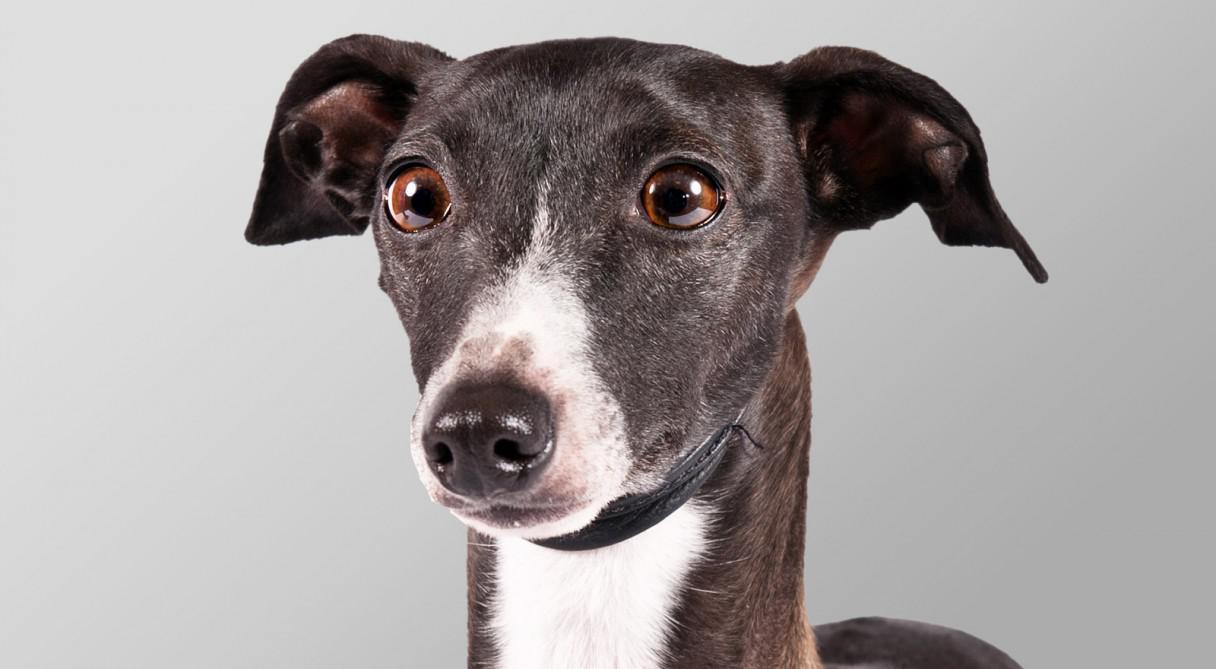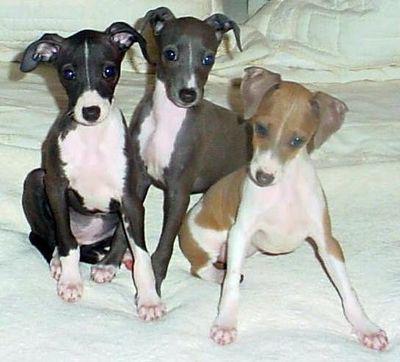The first image is the image on the left, the second image is the image on the right. Assess this claim about the two images: "There is 1 dog standing outside.". Correct or not? Answer yes or no. No. The first image is the image on the left, the second image is the image on the right. Evaluate the accuracy of this statement regarding the images: "An image contains a row of at least four dogs.". Is it true? Answer yes or no. No. 